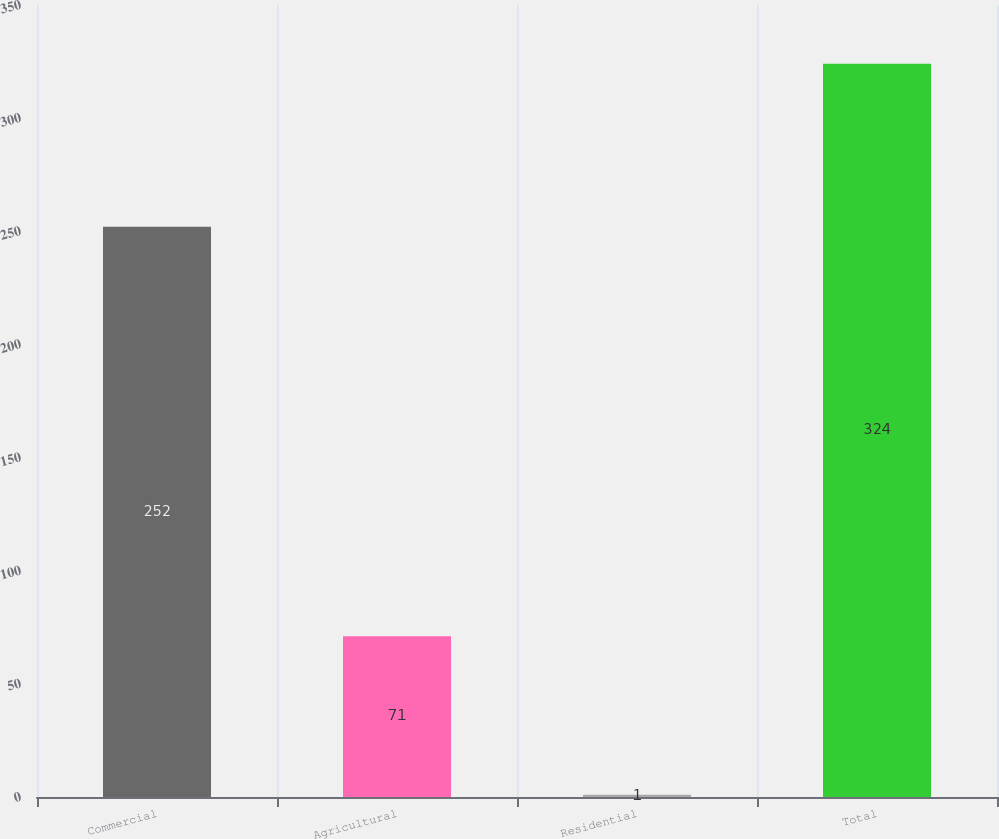Convert chart to OTSL. <chart><loc_0><loc_0><loc_500><loc_500><bar_chart><fcel>Commercial<fcel>Agricultural<fcel>Residential<fcel>Total<nl><fcel>252<fcel>71<fcel>1<fcel>324<nl></chart> 